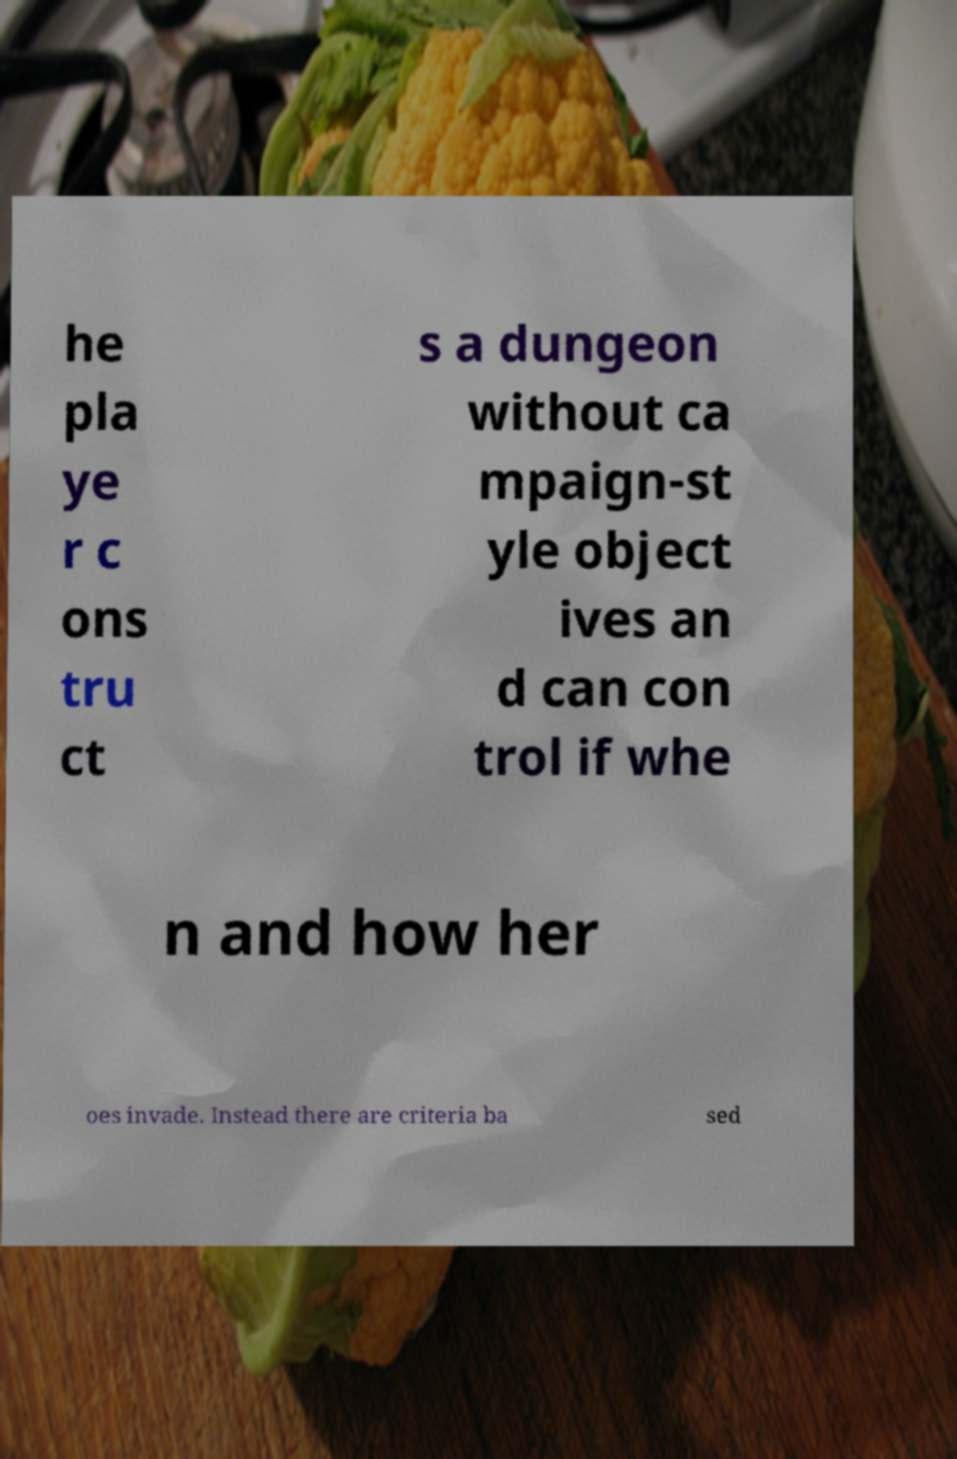Please identify and transcribe the text found in this image. he pla ye r c ons tru ct s a dungeon without ca mpaign-st yle object ives an d can con trol if whe n and how her oes invade. Instead there are criteria ba sed 